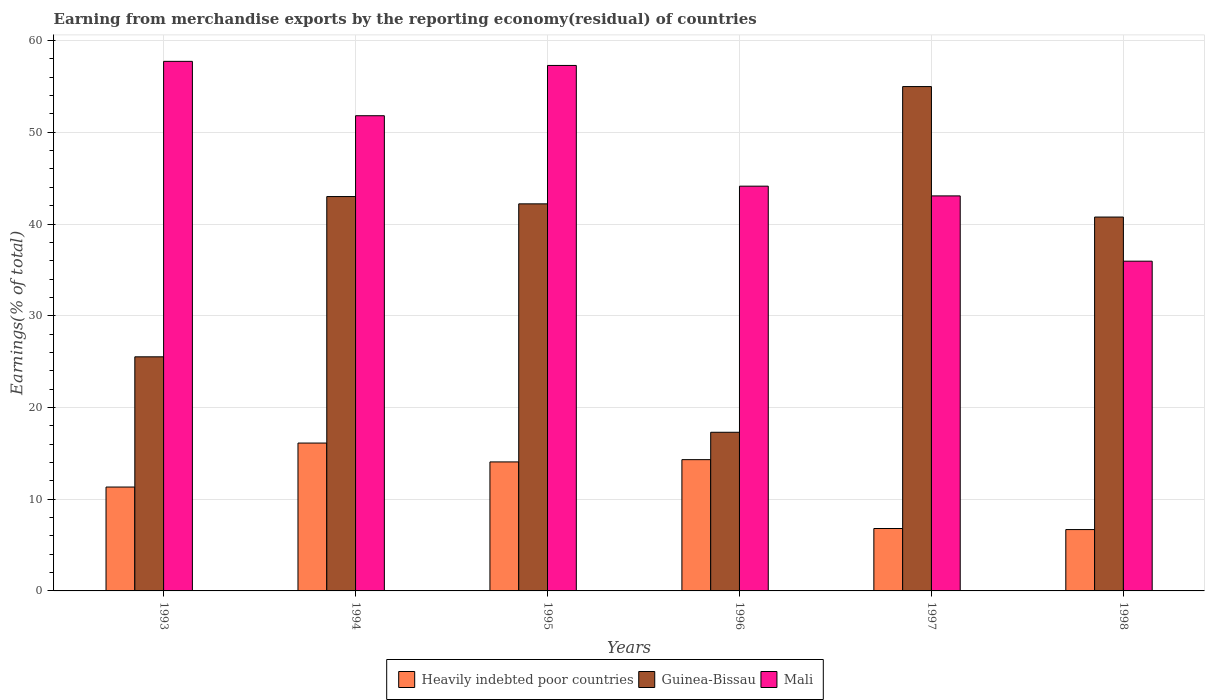How many different coloured bars are there?
Offer a very short reply. 3. How many groups of bars are there?
Keep it short and to the point. 6. Are the number of bars per tick equal to the number of legend labels?
Provide a short and direct response. Yes. Are the number of bars on each tick of the X-axis equal?
Keep it short and to the point. Yes. How many bars are there on the 6th tick from the right?
Make the answer very short. 3. What is the label of the 1st group of bars from the left?
Your answer should be compact. 1993. In how many cases, is the number of bars for a given year not equal to the number of legend labels?
Your response must be concise. 0. What is the percentage of amount earned from merchandise exports in Heavily indebted poor countries in 1993?
Keep it short and to the point. 11.32. Across all years, what is the maximum percentage of amount earned from merchandise exports in Mali?
Your response must be concise. 57.73. Across all years, what is the minimum percentage of amount earned from merchandise exports in Heavily indebted poor countries?
Your answer should be very brief. 6.69. In which year was the percentage of amount earned from merchandise exports in Heavily indebted poor countries maximum?
Offer a very short reply. 1994. In which year was the percentage of amount earned from merchandise exports in Mali minimum?
Provide a succinct answer. 1998. What is the total percentage of amount earned from merchandise exports in Guinea-Bissau in the graph?
Ensure brevity in your answer.  223.75. What is the difference between the percentage of amount earned from merchandise exports in Heavily indebted poor countries in 1996 and that in 1997?
Offer a very short reply. 7.51. What is the difference between the percentage of amount earned from merchandise exports in Heavily indebted poor countries in 1993 and the percentage of amount earned from merchandise exports in Mali in 1997?
Give a very brief answer. -31.74. What is the average percentage of amount earned from merchandise exports in Guinea-Bissau per year?
Keep it short and to the point. 37.29. In the year 1997, what is the difference between the percentage of amount earned from merchandise exports in Mali and percentage of amount earned from merchandise exports in Guinea-Bissau?
Ensure brevity in your answer.  -11.92. In how many years, is the percentage of amount earned from merchandise exports in Mali greater than 18 %?
Provide a succinct answer. 6. What is the ratio of the percentage of amount earned from merchandise exports in Heavily indebted poor countries in 1993 to that in 1996?
Your answer should be compact. 0.79. Is the percentage of amount earned from merchandise exports in Heavily indebted poor countries in 1995 less than that in 1998?
Offer a terse response. No. What is the difference between the highest and the second highest percentage of amount earned from merchandise exports in Heavily indebted poor countries?
Your answer should be compact. 1.81. What is the difference between the highest and the lowest percentage of amount earned from merchandise exports in Heavily indebted poor countries?
Give a very brief answer. 9.43. What does the 1st bar from the left in 1996 represents?
Offer a very short reply. Heavily indebted poor countries. What does the 3rd bar from the right in 1995 represents?
Your answer should be very brief. Heavily indebted poor countries. Is it the case that in every year, the sum of the percentage of amount earned from merchandise exports in Guinea-Bissau and percentage of amount earned from merchandise exports in Mali is greater than the percentage of amount earned from merchandise exports in Heavily indebted poor countries?
Ensure brevity in your answer.  Yes. How many years are there in the graph?
Your answer should be very brief. 6. What is the difference between two consecutive major ticks on the Y-axis?
Offer a terse response. 10. Where does the legend appear in the graph?
Offer a terse response. Bottom center. What is the title of the graph?
Offer a terse response. Earning from merchandise exports by the reporting economy(residual) of countries. Does "Middle East & North Africa (developing only)" appear as one of the legend labels in the graph?
Offer a very short reply. No. What is the label or title of the Y-axis?
Provide a short and direct response. Earnings(% of total). What is the Earnings(% of total) in Heavily indebted poor countries in 1993?
Offer a terse response. 11.32. What is the Earnings(% of total) in Guinea-Bissau in 1993?
Give a very brief answer. 25.52. What is the Earnings(% of total) of Mali in 1993?
Provide a succinct answer. 57.73. What is the Earnings(% of total) of Heavily indebted poor countries in 1994?
Your response must be concise. 16.12. What is the Earnings(% of total) in Guinea-Bissau in 1994?
Your answer should be very brief. 42.99. What is the Earnings(% of total) in Mali in 1994?
Your answer should be compact. 51.81. What is the Earnings(% of total) in Heavily indebted poor countries in 1995?
Make the answer very short. 14.06. What is the Earnings(% of total) in Guinea-Bissau in 1995?
Provide a short and direct response. 42.2. What is the Earnings(% of total) of Mali in 1995?
Ensure brevity in your answer.  57.29. What is the Earnings(% of total) in Heavily indebted poor countries in 1996?
Provide a succinct answer. 14.31. What is the Earnings(% of total) of Guinea-Bissau in 1996?
Provide a succinct answer. 17.3. What is the Earnings(% of total) in Mali in 1996?
Keep it short and to the point. 44.13. What is the Earnings(% of total) of Heavily indebted poor countries in 1997?
Offer a very short reply. 6.8. What is the Earnings(% of total) of Guinea-Bissau in 1997?
Your response must be concise. 54.98. What is the Earnings(% of total) of Mali in 1997?
Make the answer very short. 43.07. What is the Earnings(% of total) in Heavily indebted poor countries in 1998?
Make the answer very short. 6.69. What is the Earnings(% of total) of Guinea-Bissau in 1998?
Give a very brief answer. 40.76. What is the Earnings(% of total) of Mali in 1998?
Provide a short and direct response. 35.95. Across all years, what is the maximum Earnings(% of total) in Heavily indebted poor countries?
Provide a succinct answer. 16.12. Across all years, what is the maximum Earnings(% of total) of Guinea-Bissau?
Provide a short and direct response. 54.98. Across all years, what is the maximum Earnings(% of total) in Mali?
Your response must be concise. 57.73. Across all years, what is the minimum Earnings(% of total) in Heavily indebted poor countries?
Keep it short and to the point. 6.69. Across all years, what is the minimum Earnings(% of total) in Guinea-Bissau?
Make the answer very short. 17.3. Across all years, what is the minimum Earnings(% of total) in Mali?
Give a very brief answer. 35.95. What is the total Earnings(% of total) of Heavily indebted poor countries in the graph?
Make the answer very short. 69.31. What is the total Earnings(% of total) in Guinea-Bissau in the graph?
Offer a very short reply. 223.75. What is the total Earnings(% of total) in Mali in the graph?
Make the answer very short. 289.97. What is the difference between the Earnings(% of total) in Heavily indebted poor countries in 1993 and that in 1994?
Provide a short and direct response. -4.8. What is the difference between the Earnings(% of total) of Guinea-Bissau in 1993 and that in 1994?
Keep it short and to the point. -17.47. What is the difference between the Earnings(% of total) of Mali in 1993 and that in 1994?
Provide a succinct answer. 5.93. What is the difference between the Earnings(% of total) in Heavily indebted poor countries in 1993 and that in 1995?
Your answer should be compact. -2.74. What is the difference between the Earnings(% of total) in Guinea-Bissau in 1993 and that in 1995?
Your answer should be very brief. -16.68. What is the difference between the Earnings(% of total) of Mali in 1993 and that in 1995?
Make the answer very short. 0.45. What is the difference between the Earnings(% of total) of Heavily indebted poor countries in 1993 and that in 1996?
Keep it short and to the point. -2.99. What is the difference between the Earnings(% of total) of Guinea-Bissau in 1993 and that in 1996?
Give a very brief answer. 8.23. What is the difference between the Earnings(% of total) in Mali in 1993 and that in 1996?
Give a very brief answer. 13.61. What is the difference between the Earnings(% of total) of Heavily indebted poor countries in 1993 and that in 1997?
Keep it short and to the point. 4.52. What is the difference between the Earnings(% of total) in Guinea-Bissau in 1993 and that in 1997?
Make the answer very short. -29.46. What is the difference between the Earnings(% of total) in Mali in 1993 and that in 1997?
Offer a very short reply. 14.67. What is the difference between the Earnings(% of total) of Heavily indebted poor countries in 1993 and that in 1998?
Offer a terse response. 4.64. What is the difference between the Earnings(% of total) of Guinea-Bissau in 1993 and that in 1998?
Your answer should be very brief. -15.24. What is the difference between the Earnings(% of total) of Mali in 1993 and that in 1998?
Offer a terse response. 21.78. What is the difference between the Earnings(% of total) in Heavily indebted poor countries in 1994 and that in 1995?
Offer a very short reply. 2.06. What is the difference between the Earnings(% of total) of Guinea-Bissau in 1994 and that in 1995?
Make the answer very short. 0.79. What is the difference between the Earnings(% of total) in Mali in 1994 and that in 1995?
Provide a short and direct response. -5.48. What is the difference between the Earnings(% of total) of Heavily indebted poor countries in 1994 and that in 1996?
Make the answer very short. 1.81. What is the difference between the Earnings(% of total) in Guinea-Bissau in 1994 and that in 1996?
Make the answer very short. 25.7. What is the difference between the Earnings(% of total) of Mali in 1994 and that in 1996?
Your answer should be compact. 7.68. What is the difference between the Earnings(% of total) in Heavily indebted poor countries in 1994 and that in 1997?
Ensure brevity in your answer.  9.32. What is the difference between the Earnings(% of total) in Guinea-Bissau in 1994 and that in 1997?
Make the answer very short. -11.99. What is the difference between the Earnings(% of total) of Mali in 1994 and that in 1997?
Give a very brief answer. 8.74. What is the difference between the Earnings(% of total) in Heavily indebted poor countries in 1994 and that in 1998?
Your answer should be very brief. 9.43. What is the difference between the Earnings(% of total) in Guinea-Bissau in 1994 and that in 1998?
Your response must be concise. 2.23. What is the difference between the Earnings(% of total) in Mali in 1994 and that in 1998?
Make the answer very short. 15.86. What is the difference between the Earnings(% of total) in Heavily indebted poor countries in 1995 and that in 1996?
Your answer should be compact. -0.25. What is the difference between the Earnings(% of total) in Guinea-Bissau in 1995 and that in 1996?
Keep it short and to the point. 24.9. What is the difference between the Earnings(% of total) of Mali in 1995 and that in 1996?
Your answer should be compact. 13.16. What is the difference between the Earnings(% of total) in Heavily indebted poor countries in 1995 and that in 1997?
Provide a succinct answer. 7.26. What is the difference between the Earnings(% of total) of Guinea-Bissau in 1995 and that in 1997?
Your response must be concise. -12.79. What is the difference between the Earnings(% of total) of Mali in 1995 and that in 1997?
Your answer should be compact. 14.22. What is the difference between the Earnings(% of total) of Heavily indebted poor countries in 1995 and that in 1998?
Provide a short and direct response. 7.38. What is the difference between the Earnings(% of total) in Guinea-Bissau in 1995 and that in 1998?
Provide a short and direct response. 1.44. What is the difference between the Earnings(% of total) of Mali in 1995 and that in 1998?
Provide a short and direct response. 21.34. What is the difference between the Earnings(% of total) in Heavily indebted poor countries in 1996 and that in 1997?
Your response must be concise. 7.51. What is the difference between the Earnings(% of total) in Guinea-Bissau in 1996 and that in 1997?
Offer a very short reply. -37.69. What is the difference between the Earnings(% of total) in Mali in 1996 and that in 1997?
Offer a very short reply. 1.06. What is the difference between the Earnings(% of total) of Heavily indebted poor countries in 1996 and that in 1998?
Keep it short and to the point. 7.62. What is the difference between the Earnings(% of total) in Guinea-Bissau in 1996 and that in 1998?
Your response must be concise. -23.46. What is the difference between the Earnings(% of total) in Mali in 1996 and that in 1998?
Provide a succinct answer. 8.18. What is the difference between the Earnings(% of total) in Heavily indebted poor countries in 1997 and that in 1998?
Your answer should be compact. 0.12. What is the difference between the Earnings(% of total) in Guinea-Bissau in 1997 and that in 1998?
Give a very brief answer. 14.23. What is the difference between the Earnings(% of total) of Mali in 1997 and that in 1998?
Offer a very short reply. 7.12. What is the difference between the Earnings(% of total) of Heavily indebted poor countries in 1993 and the Earnings(% of total) of Guinea-Bissau in 1994?
Offer a terse response. -31.67. What is the difference between the Earnings(% of total) of Heavily indebted poor countries in 1993 and the Earnings(% of total) of Mali in 1994?
Ensure brevity in your answer.  -40.48. What is the difference between the Earnings(% of total) of Guinea-Bissau in 1993 and the Earnings(% of total) of Mali in 1994?
Make the answer very short. -26.28. What is the difference between the Earnings(% of total) of Heavily indebted poor countries in 1993 and the Earnings(% of total) of Guinea-Bissau in 1995?
Provide a short and direct response. -30.87. What is the difference between the Earnings(% of total) of Heavily indebted poor countries in 1993 and the Earnings(% of total) of Mali in 1995?
Keep it short and to the point. -45.96. What is the difference between the Earnings(% of total) in Guinea-Bissau in 1993 and the Earnings(% of total) in Mali in 1995?
Make the answer very short. -31.77. What is the difference between the Earnings(% of total) of Heavily indebted poor countries in 1993 and the Earnings(% of total) of Guinea-Bissau in 1996?
Keep it short and to the point. -5.97. What is the difference between the Earnings(% of total) of Heavily indebted poor countries in 1993 and the Earnings(% of total) of Mali in 1996?
Give a very brief answer. -32.8. What is the difference between the Earnings(% of total) of Guinea-Bissau in 1993 and the Earnings(% of total) of Mali in 1996?
Your response must be concise. -18.6. What is the difference between the Earnings(% of total) of Heavily indebted poor countries in 1993 and the Earnings(% of total) of Guinea-Bissau in 1997?
Offer a very short reply. -43.66. What is the difference between the Earnings(% of total) in Heavily indebted poor countries in 1993 and the Earnings(% of total) in Mali in 1997?
Keep it short and to the point. -31.74. What is the difference between the Earnings(% of total) in Guinea-Bissau in 1993 and the Earnings(% of total) in Mali in 1997?
Offer a terse response. -17.54. What is the difference between the Earnings(% of total) in Heavily indebted poor countries in 1993 and the Earnings(% of total) in Guinea-Bissau in 1998?
Provide a succinct answer. -29.43. What is the difference between the Earnings(% of total) in Heavily indebted poor countries in 1993 and the Earnings(% of total) in Mali in 1998?
Keep it short and to the point. -24.62. What is the difference between the Earnings(% of total) of Guinea-Bissau in 1993 and the Earnings(% of total) of Mali in 1998?
Make the answer very short. -10.43. What is the difference between the Earnings(% of total) of Heavily indebted poor countries in 1994 and the Earnings(% of total) of Guinea-Bissau in 1995?
Provide a succinct answer. -26.08. What is the difference between the Earnings(% of total) of Heavily indebted poor countries in 1994 and the Earnings(% of total) of Mali in 1995?
Provide a short and direct response. -41.17. What is the difference between the Earnings(% of total) in Guinea-Bissau in 1994 and the Earnings(% of total) in Mali in 1995?
Give a very brief answer. -14.29. What is the difference between the Earnings(% of total) in Heavily indebted poor countries in 1994 and the Earnings(% of total) in Guinea-Bissau in 1996?
Your response must be concise. -1.18. What is the difference between the Earnings(% of total) in Heavily indebted poor countries in 1994 and the Earnings(% of total) in Mali in 1996?
Make the answer very short. -28.01. What is the difference between the Earnings(% of total) in Guinea-Bissau in 1994 and the Earnings(% of total) in Mali in 1996?
Your answer should be compact. -1.13. What is the difference between the Earnings(% of total) in Heavily indebted poor countries in 1994 and the Earnings(% of total) in Guinea-Bissau in 1997?
Provide a succinct answer. -38.86. What is the difference between the Earnings(% of total) of Heavily indebted poor countries in 1994 and the Earnings(% of total) of Mali in 1997?
Your answer should be very brief. -26.95. What is the difference between the Earnings(% of total) in Guinea-Bissau in 1994 and the Earnings(% of total) in Mali in 1997?
Offer a very short reply. -0.07. What is the difference between the Earnings(% of total) of Heavily indebted poor countries in 1994 and the Earnings(% of total) of Guinea-Bissau in 1998?
Keep it short and to the point. -24.64. What is the difference between the Earnings(% of total) in Heavily indebted poor countries in 1994 and the Earnings(% of total) in Mali in 1998?
Provide a short and direct response. -19.83. What is the difference between the Earnings(% of total) in Guinea-Bissau in 1994 and the Earnings(% of total) in Mali in 1998?
Make the answer very short. 7.04. What is the difference between the Earnings(% of total) of Heavily indebted poor countries in 1995 and the Earnings(% of total) of Guinea-Bissau in 1996?
Offer a terse response. -3.23. What is the difference between the Earnings(% of total) in Heavily indebted poor countries in 1995 and the Earnings(% of total) in Mali in 1996?
Ensure brevity in your answer.  -30.06. What is the difference between the Earnings(% of total) in Guinea-Bissau in 1995 and the Earnings(% of total) in Mali in 1996?
Give a very brief answer. -1.93. What is the difference between the Earnings(% of total) of Heavily indebted poor countries in 1995 and the Earnings(% of total) of Guinea-Bissau in 1997?
Give a very brief answer. -40.92. What is the difference between the Earnings(% of total) of Heavily indebted poor countries in 1995 and the Earnings(% of total) of Mali in 1997?
Your response must be concise. -29. What is the difference between the Earnings(% of total) of Guinea-Bissau in 1995 and the Earnings(% of total) of Mali in 1997?
Your response must be concise. -0.87. What is the difference between the Earnings(% of total) of Heavily indebted poor countries in 1995 and the Earnings(% of total) of Guinea-Bissau in 1998?
Your response must be concise. -26.69. What is the difference between the Earnings(% of total) of Heavily indebted poor countries in 1995 and the Earnings(% of total) of Mali in 1998?
Offer a terse response. -21.88. What is the difference between the Earnings(% of total) in Guinea-Bissau in 1995 and the Earnings(% of total) in Mali in 1998?
Offer a terse response. 6.25. What is the difference between the Earnings(% of total) in Heavily indebted poor countries in 1996 and the Earnings(% of total) in Guinea-Bissau in 1997?
Provide a succinct answer. -40.67. What is the difference between the Earnings(% of total) in Heavily indebted poor countries in 1996 and the Earnings(% of total) in Mali in 1997?
Ensure brevity in your answer.  -28.75. What is the difference between the Earnings(% of total) of Guinea-Bissau in 1996 and the Earnings(% of total) of Mali in 1997?
Offer a terse response. -25.77. What is the difference between the Earnings(% of total) of Heavily indebted poor countries in 1996 and the Earnings(% of total) of Guinea-Bissau in 1998?
Offer a very short reply. -26.45. What is the difference between the Earnings(% of total) of Heavily indebted poor countries in 1996 and the Earnings(% of total) of Mali in 1998?
Your answer should be very brief. -21.64. What is the difference between the Earnings(% of total) of Guinea-Bissau in 1996 and the Earnings(% of total) of Mali in 1998?
Offer a terse response. -18.65. What is the difference between the Earnings(% of total) of Heavily indebted poor countries in 1997 and the Earnings(% of total) of Guinea-Bissau in 1998?
Provide a short and direct response. -33.95. What is the difference between the Earnings(% of total) in Heavily indebted poor countries in 1997 and the Earnings(% of total) in Mali in 1998?
Give a very brief answer. -29.15. What is the difference between the Earnings(% of total) in Guinea-Bissau in 1997 and the Earnings(% of total) in Mali in 1998?
Give a very brief answer. 19.04. What is the average Earnings(% of total) in Heavily indebted poor countries per year?
Offer a terse response. 11.55. What is the average Earnings(% of total) in Guinea-Bissau per year?
Your response must be concise. 37.29. What is the average Earnings(% of total) of Mali per year?
Ensure brevity in your answer.  48.33. In the year 1993, what is the difference between the Earnings(% of total) of Heavily indebted poor countries and Earnings(% of total) of Guinea-Bissau?
Provide a succinct answer. -14.2. In the year 1993, what is the difference between the Earnings(% of total) of Heavily indebted poor countries and Earnings(% of total) of Mali?
Give a very brief answer. -46.41. In the year 1993, what is the difference between the Earnings(% of total) of Guinea-Bissau and Earnings(% of total) of Mali?
Your answer should be compact. -32.21. In the year 1994, what is the difference between the Earnings(% of total) in Heavily indebted poor countries and Earnings(% of total) in Guinea-Bissau?
Offer a very short reply. -26.87. In the year 1994, what is the difference between the Earnings(% of total) in Heavily indebted poor countries and Earnings(% of total) in Mali?
Your answer should be very brief. -35.69. In the year 1994, what is the difference between the Earnings(% of total) in Guinea-Bissau and Earnings(% of total) in Mali?
Make the answer very short. -8.81. In the year 1995, what is the difference between the Earnings(% of total) in Heavily indebted poor countries and Earnings(% of total) in Guinea-Bissau?
Your answer should be compact. -28.13. In the year 1995, what is the difference between the Earnings(% of total) in Heavily indebted poor countries and Earnings(% of total) in Mali?
Provide a succinct answer. -43.22. In the year 1995, what is the difference between the Earnings(% of total) in Guinea-Bissau and Earnings(% of total) in Mali?
Offer a terse response. -15.09. In the year 1996, what is the difference between the Earnings(% of total) of Heavily indebted poor countries and Earnings(% of total) of Guinea-Bissau?
Offer a terse response. -2.98. In the year 1996, what is the difference between the Earnings(% of total) of Heavily indebted poor countries and Earnings(% of total) of Mali?
Offer a very short reply. -29.81. In the year 1996, what is the difference between the Earnings(% of total) of Guinea-Bissau and Earnings(% of total) of Mali?
Your answer should be very brief. -26.83. In the year 1997, what is the difference between the Earnings(% of total) of Heavily indebted poor countries and Earnings(% of total) of Guinea-Bissau?
Provide a short and direct response. -48.18. In the year 1997, what is the difference between the Earnings(% of total) of Heavily indebted poor countries and Earnings(% of total) of Mali?
Give a very brief answer. -36.26. In the year 1997, what is the difference between the Earnings(% of total) in Guinea-Bissau and Earnings(% of total) in Mali?
Give a very brief answer. 11.92. In the year 1998, what is the difference between the Earnings(% of total) in Heavily indebted poor countries and Earnings(% of total) in Guinea-Bissau?
Your answer should be very brief. -34.07. In the year 1998, what is the difference between the Earnings(% of total) of Heavily indebted poor countries and Earnings(% of total) of Mali?
Provide a succinct answer. -29.26. In the year 1998, what is the difference between the Earnings(% of total) of Guinea-Bissau and Earnings(% of total) of Mali?
Keep it short and to the point. 4.81. What is the ratio of the Earnings(% of total) in Heavily indebted poor countries in 1993 to that in 1994?
Your answer should be very brief. 0.7. What is the ratio of the Earnings(% of total) in Guinea-Bissau in 1993 to that in 1994?
Ensure brevity in your answer.  0.59. What is the ratio of the Earnings(% of total) of Mali in 1993 to that in 1994?
Provide a short and direct response. 1.11. What is the ratio of the Earnings(% of total) of Heavily indebted poor countries in 1993 to that in 1995?
Your answer should be very brief. 0.81. What is the ratio of the Earnings(% of total) of Guinea-Bissau in 1993 to that in 1995?
Make the answer very short. 0.6. What is the ratio of the Earnings(% of total) of Mali in 1993 to that in 1995?
Your answer should be very brief. 1.01. What is the ratio of the Earnings(% of total) in Heavily indebted poor countries in 1993 to that in 1996?
Ensure brevity in your answer.  0.79. What is the ratio of the Earnings(% of total) in Guinea-Bissau in 1993 to that in 1996?
Provide a short and direct response. 1.48. What is the ratio of the Earnings(% of total) in Mali in 1993 to that in 1996?
Ensure brevity in your answer.  1.31. What is the ratio of the Earnings(% of total) of Heavily indebted poor countries in 1993 to that in 1997?
Your answer should be compact. 1.66. What is the ratio of the Earnings(% of total) of Guinea-Bissau in 1993 to that in 1997?
Your response must be concise. 0.46. What is the ratio of the Earnings(% of total) of Mali in 1993 to that in 1997?
Ensure brevity in your answer.  1.34. What is the ratio of the Earnings(% of total) in Heavily indebted poor countries in 1993 to that in 1998?
Give a very brief answer. 1.69. What is the ratio of the Earnings(% of total) of Guinea-Bissau in 1993 to that in 1998?
Your answer should be very brief. 0.63. What is the ratio of the Earnings(% of total) in Mali in 1993 to that in 1998?
Give a very brief answer. 1.61. What is the ratio of the Earnings(% of total) in Heavily indebted poor countries in 1994 to that in 1995?
Your response must be concise. 1.15. What is the ratio of the Earnings(% of total) of Guinea-Bissau in 1994 to that in 1995?
Your response must be concise. 1.02. What is the ratio of the Earnings(% of total) of Mali in 1994 to that in 1995?
Offer a terse response. 0.9. What is the ratio of the Earnings(% of total) in Heavily indebted poor countries in 1994 to that in 1996?
Offer a terse response. 1.13. What is the ratio of the Earnings(% of total) in Guinea-Bissau in 1994 to that in 1996?
Your response must be concise. 2.49. What is the ratio of the Earnings(% of total) in Mali in 1994 to that in 1996?
Ensure brevity in your answer.  1.17. What is the ratio of the Earnings(% of total) in Heavily indebted poor countries in 1994 to that in 1997?
Offer a terse response. 2.37. What is the ratio of the Earnings(% of total) in Guinea-Bissau in 1994 to that in 1997?
Your answer should be very brief. 0.78. What is the ratio of the Earnings(% of total) of Mali in 1994 to that in 1997?
Ensure brevity in your answer.  1.2. What is the ratio of the Earnings(% of total) in Heavily indebted poor countries in 1994 to that in 1998?
Provide a succinct answer. 2.41. What is the ratio of the Earnings(% of total) of Guinea-Bissau in 1994 to that in 1998?
Ensure brevity in your answer.  1.05. What is the ratio of the Earnings(% of total) of Mali in 1994 to that in 1998?
Give a very brief answer. 1.44. What is the ratio of the Earnings(% of total) of Heavily indebted poor countries in 1995 to that in 1996?
Provide a short and direct response. 0.98. What is the ratio of the Earnings(% of total) in Guinea-Bissau in 1995 to that in 1996?
Offer a terse response. 2.44. What is the ratio of the Earnings(% of total) of Mali in 1995 to that in 1996?
Offer a terse response. 1.3. What is the ratio of the Earnings(% of total) in Heavily indebted poor countries in 1995 to that in 1997?
Ensure brevity in your answer.  2.07. What is the ratio of the Earnings(% of total) in Guinea-Bissau in 1995 to that in 1997?
Give a very brief answer. 0.77. What is the ratio of the Earnings(% of total) in Mali in 1995 to that in 1997?
Give a very brief answer. 1.33. What is the ratio of the Earnings(% of total) of Heavily indebted poor countries in 1995 to that in 1998?
Ensure brevity in your answer.  2.1. What is the ratio of the Earnings(% of total) in Guinea-Bissau in 1995 to that in 1998?
Give a very brief answer. 1.04. What is the ratio of the Earnings(% of total) of Mali in 1995 to that in 1998?
Offer a terse response. 1.59. What is the ratio of the Earnings(% of total) of Heavily indebted poor countries in 1996 to that in 1997?
Give a very brief answer. 2.1. What is the ratio of the Earnings(% of total) of Guinea-Bissau in 1996 to that in 1997?
Offer a very short reply. 0.31. What is the ratio of the Earnings(% of total) in Mali in 1996 to that in 1997?
Keep it short and to the point. 1.02. What is the ratio of the Earnings(% of total) of Heavily indebted poor countries in 1996 to that in 1998?
Your answer should be very brief. 2.14. What is the ratio of the Earnings(% of total) in Guinea-Bissau in 1996 to that in 1998?
Provide a short and direct response. 0.42. What is the ratio of the Earnings(% of total) of Mali in 1996 to that in 1998?
Give a very brief answer. 1.23. What is the ratio of the Earnings(% of total) in Heavily indebted poor countries in 1997 to that in 1998?
Offer a terse response. 1.02. What is the ratio of the Earnings(% of total) in Guinea-Bissau in 1997 to that in 1998?
Provide a short and direct response. 1.35. What is the ratio of the Earnings(% of total) in Mali in 1997 to that in 1998?
Give a very brief answer. 1.2. What is the difference between the highest and the second highest Earnings(% of total) in Heavily indebted poor countries?
Ensure brevity in your answer.  1.81. What is the difference between the highest and the second highest Earnings(% of total) of Guinea-Bissau?
Your answer should be very brief. 11.99. What is the difference between the highest and the second highest Earnings(% of total) of Mali?
Ensure brevity in your answer.  0.45. What is the difference between the highest and the lowest Earnings(% of total) of Heavily indebted poor countries?
Provide a succinct answer. 9.43. What is the difference between the highest and the lowest Earnings(% of total) of Guinea-Bissau?
Your answer should be compact. 37.69. What is the difference between the highest and the lowest Earnings(% of total) in Mali?
Offer a very short reply. 21.78. 